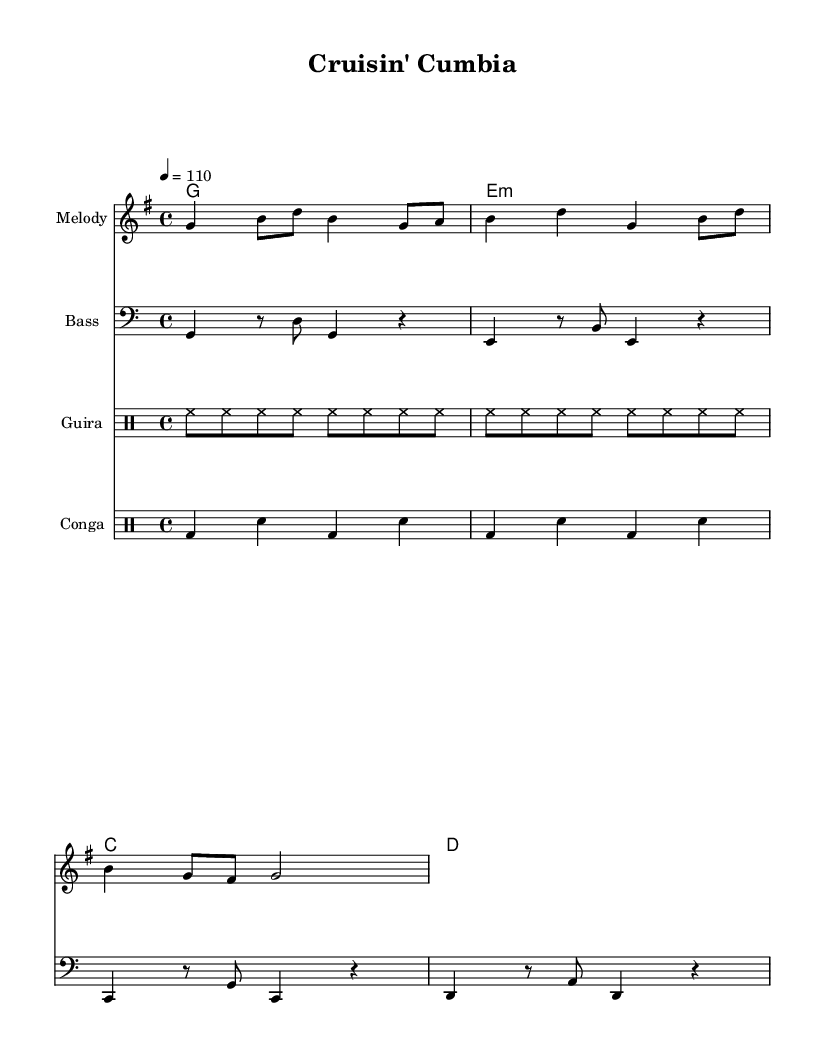What is the key signature of this music? The key signature is G major, which has one sharp (F#).
Answer: G major What is the time signature of the piece? The time signature is 4/4, indicating there are four beats in each measure.
Answer: 4/4 What is the tempo marking? The tempo marking is quarter note equals 110 beats per minute, indicating a moderate speed for the music.
Answer: 110 How many measures are there in the melody? There are four complete measures in the melody section as indicated by the notation.
Answer: Four Which instruments are indicated in the score? The score includes Melody, Bass, Guira, and Conga as specified in the staff headers.
Answer: Melody, Bass, Guira, Conga What is the characteristic rhythm used in the guira part? The characteristic rhythm in the guira part consists of repeated eighth notes (hi-hat sounds).
Answer: Eighth notes What is the primary chord progression used in this piece? The primary chord progression is G, E minor, C, D, following a typical cumbia structure.
Answer: G, E minor, C, D 